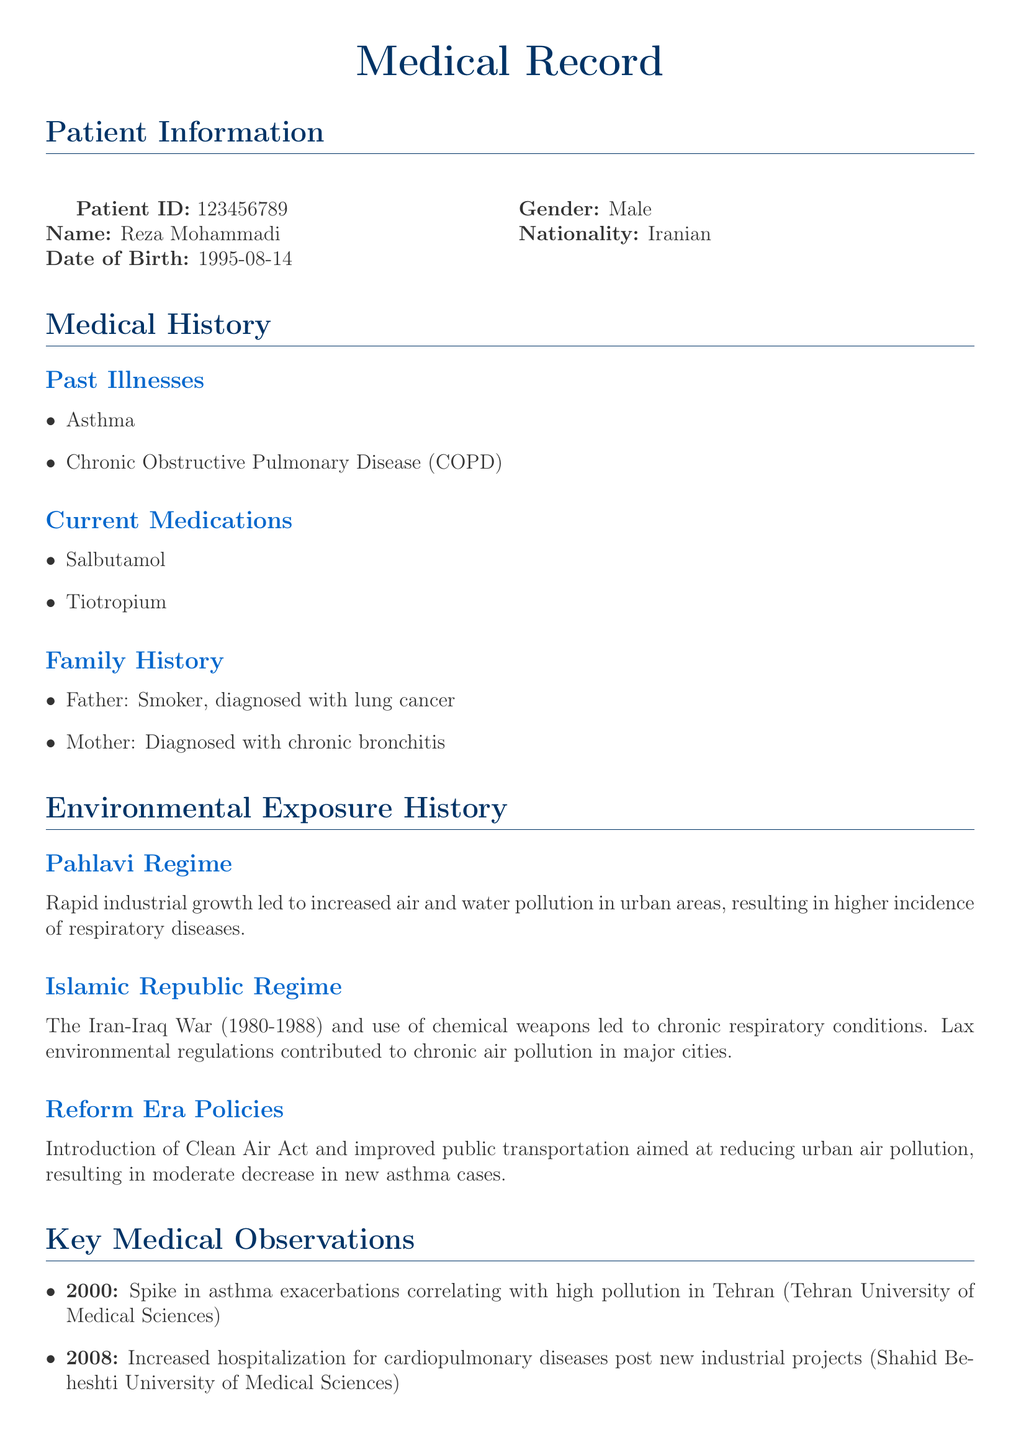What is the patient's name? The patient's name is explicitly mentioned in the patient information section of the document.
Answer: Reza Mohammadi What illnesses did the patient have in the past? The past illnesses are listed in the medical history section of the document.
Answer: Asthma, Chronic Obstructive Pulmonary Disease What medications is the patient currently taking? The current medications are specified in the medical history section of the document.
Answer: Salbutamol, Tiotropium In which year did a spike in asthma exacerbations occur? The specific year is noted in the key medical observations section of the document.
Answer: 2000 What environmental issue was reported during the Pahlavi regime? The document states the impact of industrial growth on pollution levels during this regime.
Answer: Increased air and water pollution What was a significant policy introduced during the Reform Era? The document mentions policies aimed at reducing urban air pollution during the Reform Era.
Answer: Clean Air Act How many family members have respiratory-related illnesses? The family history section lists conditions affecting family members.
Answer: Two What respiratory condition was linked to the Iran-Iraq war? The document outlines chronic conditions resulting from the conflict.
Answer: Chronic respiratory conditions What does the conclusion emphasize about environmental regulations? The conclusion highlights the necessity of regulations based on the study findings.
Answer: Stringent and consistent environmental regulations 